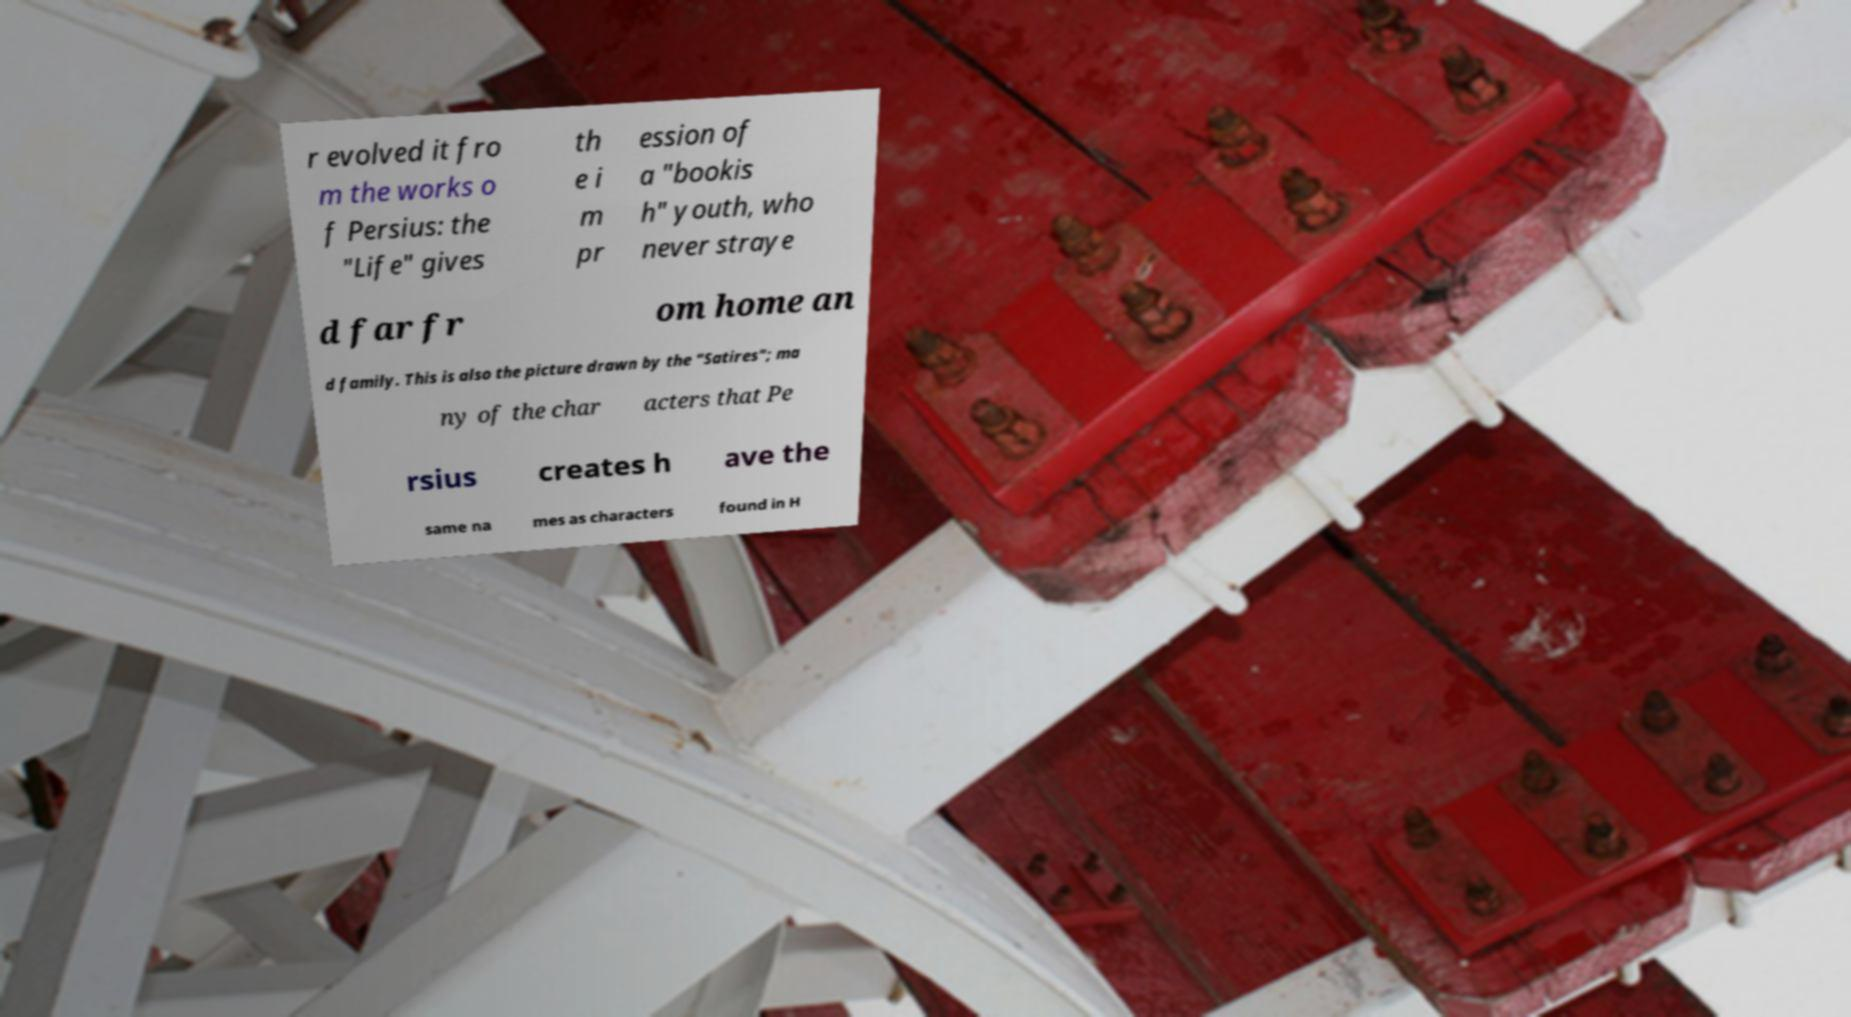Please read and relay the text visible in this image. What does it say? r evolved it fro m the works o f Persius: the "Life" gives th e i m pr ession of a "bookis h" youth, who never straye d far fr om home an d family. This is also the picture drawn by the "Satires"; ma ny of the char acters that Pe rsius creates h ave the same na mes as characters found in H 